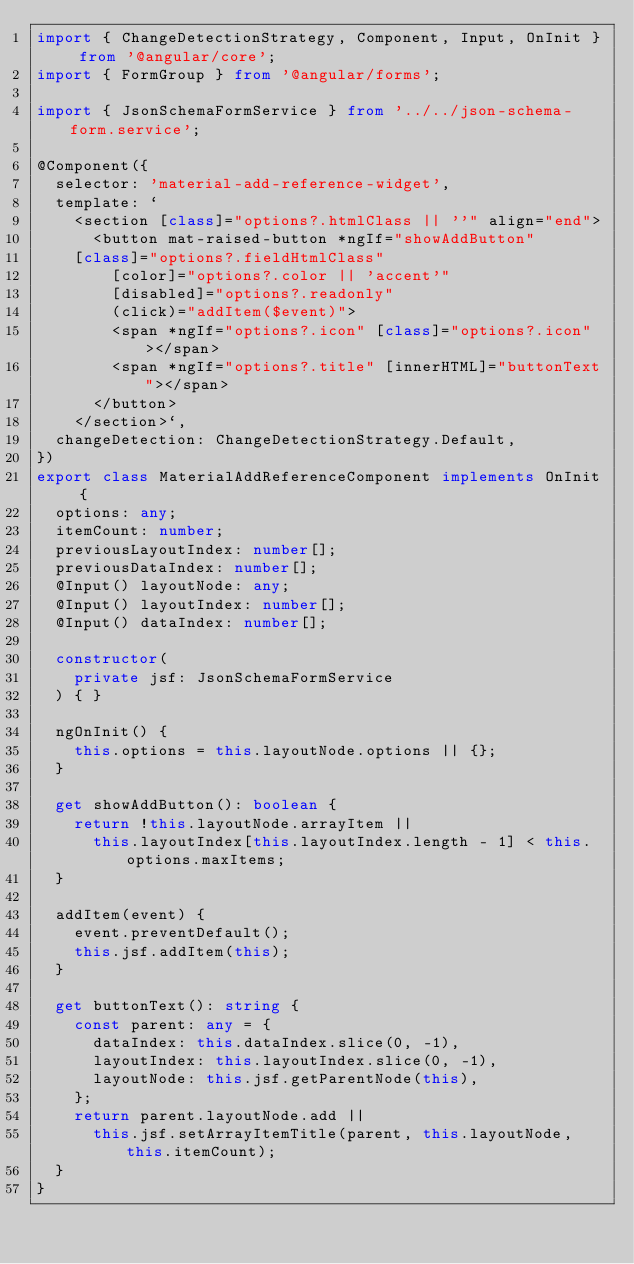<code> <loc_0><loc_0><loc_500><loc_500><_TypeScript_>import { ChangeDetectionStrategy, Component, Input, OnInit } from '@angular/core';
import { FormGroup } from '@angular/forms';

import { JsonSchemaFormService } from '../../json-schema-form.service';

@Component({
  selector: 'material-add-reference-widget',
  template: `
    <section [class]="options?.htmlClass || ''" align="end">
      <button mat-raised-button *ngIf="showAddButton"
		[class]="options?.fieldHtmlClass"
        [color]="options?.color || 'accent'"
        [disabled]="options?.readonly"
        (click)="addItem($event)">
        <span *ngIf="options?.icon" [class]="options?.icon"></span>
        <span *ngIf="options?.title" [innerHTML]="buttonText"></span>
      </button>
    </section>`,
  changeDetection: ChangeDetectionStrategy.Default,
})
export class MaterialAddReferenceComponent implements OnInit {
  options: any;
  itemCount: number;
  previousLayoutIndex: number[];
  previousDataIndex: number[];
  @Input() layoutNode: any;
  @Input() layoutIndex: number[];
  @Input() dataIndex: number[];

  constructor(
    private jsf: JsonSchemaFormService
  ) { }

  ngOnInit() {
    this.options = this.layoutNode.options || {};
  }

  get showAddButton(): boolean {
    return !this.layoutNode.arrayItem ||
      this.layoutIndex[this.layoutIndex.length - 1] < this.options.maxItems;
  }

  addItem(event) {
    event.preventDefault();
    this.jsf.addItem(this);
  }

  get buttonText(): string {
    const parent: any = {
      dataIndex: this.dataIndex.slice(0, -1),
      layoutIndex: this.layoutIndex.slice(0, -1),
      layoutNode: this.jsf.getParentNode(this),
    };
    return parent.layoutNode.add ||
      this.jsf.setArrayItemTitle(parent, this.layoutNode, this.itemCount);
  }
}
</code> 